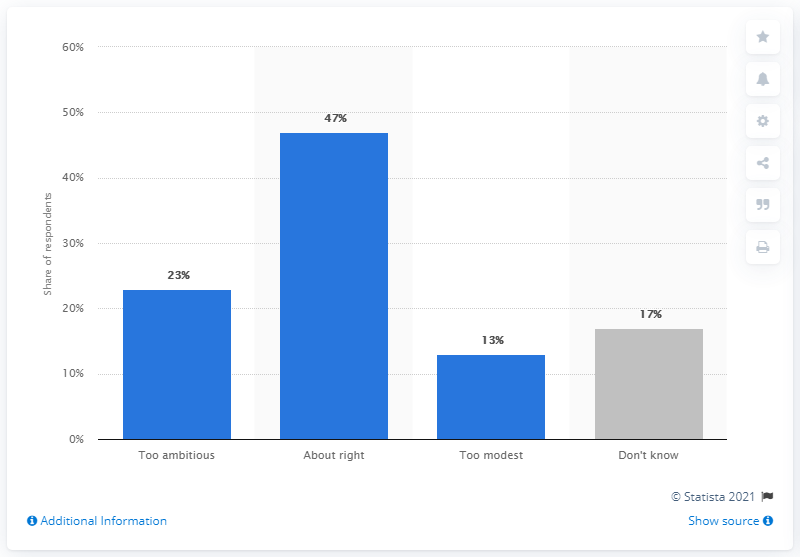Identify some key points in this picture. According to the data, 23% of the respondents believed that the 2020 EU goal was too ambitious. 